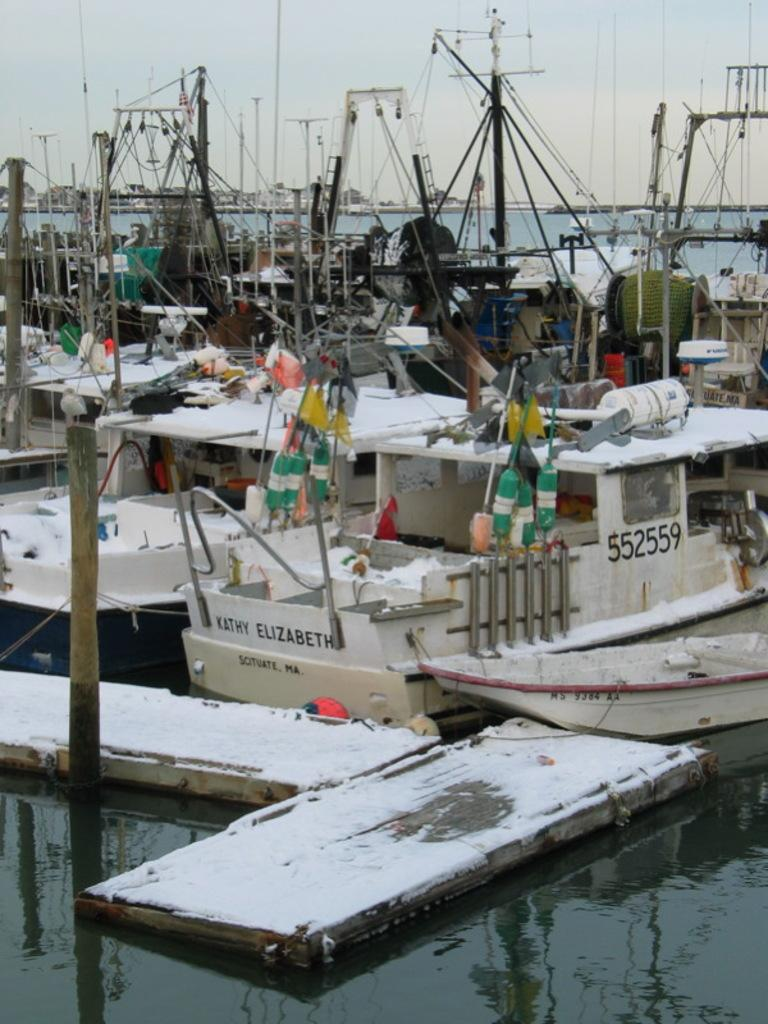What can be seen in the foreground of the image? There are boats near a dock and wooden poles in the foreground of the image. What is visible in the background of the image? There is water and the sky visible in the background of the image. What type of environment is depicted in the image? The image depicts a waterfront environment with boats and a dock. What type of milk is being used for digestion in the image? There is no milk or digestion present in the image; it depicts a waterfront environment with boats and a dock. 